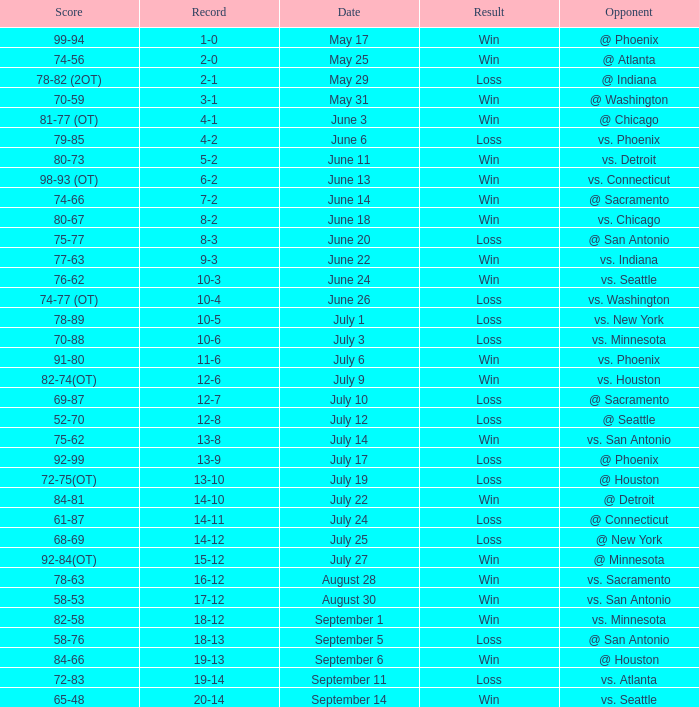Would you be able to parse every entry in this table? {'header': ['Score', 'Record', 'Date', 'Result', 'Opponent'], 'rows': [['99-94', '1-0', 'May 17', 'Win', '@ Phoenix'], ['74-56', '2-0', 'May 25', 'Win', '@ Atlanta'], ['78-82 (2OT)', '2-1', 'May 29', 'Loss', '@ Indiana'], ['70-59', '3-1', 'May 31', 'Win', '@ Washington'], ['81-77 (OT)', '4-1', 'June 3', 'Win', '@ Chicago'], ['79-85', '4-2', 'June 6', 'Loss', 'vs. Phoenix'], ['80-73', '5-2', 'June 11', 'Win', 'vs. Detroit'], ['98-93 (OT)', '6-2', 'June 13', 'Win', 'vs. Connecticut'], ['74-66', '7-2', 'June 14', 'Win', '@ Sacramento'], ['80-67', '8-2', 'June 18', 'Win', 'vs. Chicago'], ['75-77', '8-3', 'June 20', 'Loss', '@ San Antonio'], ['77-63', '9-3', 'June 22', 'Win', 'vs. Indiana'], ['76-62', '10-3', 'June 24', 'Win', 'vs. Seattle'], ['74-77 (OT)', '10-4', 'June 26', 'Loss', 'vs. Washington'], ['78-89', '10-5', 'July 1', 'Loss', 'vs. New York'], ['70-88', '10-6', 'July 3', 'Loss', 'vs. Minnesota'], ['91-80', '11-6', 'July 6', 'Win', 'vs. Phoenix'], ['82-74(OT)', '12-6', 'July 9', 'Win', 'vs. Houston'], ['69-87', '12-7', 'July 10', 'Loss', '@ Sacramento'], ['52-70', '12-8', 'July 12', 'Loss', '@ Seattle'], ['75-62', '13-8', 'July 14', 'Win', 'vs. San Antonio'], ['92-99', '13-9', 'July 17', 'Loss', '@ Phoenix'], ['72-75(OT)', '13-10', 'July 19', 'Loss', '@ Houston'], ['84-81', '14-10', 'July 22', 'Win', '@ Detroit'], ['61-87', '14-11', 'July 24', 'Loss', '@ Connecticut'], ['68-69', '14-12', 'July 25', 'Loss', '@ New York'], ['92-84(OT)', '15-12', 'July 27', 'Win', '@ Minnesota'], ['78-63', '16-12', 'August 28', 'Win', 'vs. Sacramento'], ['58-53', '17-12', 'August 30', 'Win', 'vs. San Antonio'], ['82-58', '18-12', 'September 1', 'Win', 'vs. Minnesota'], ['58-76', '18-13', 'September 5', 'Loss', '@ San Antonio'], ['84-66', '19-13', 'September 6', 'Win', '@ Houston'], ['72-83', '19-14', 'September 11', 'Loss', 'vs. Atlanta'], ['65-48', '20-14', 'September 14', 'Win', 'vs. Seattle']]} What is the Score of the game @ San Antonio on June 20? 75-77. 